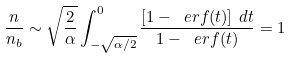<formula> <loc_0><loc_0><loc_500><loc_500>\frac { n } { n _ { b } } \sim \sqrt { \frac { 2 } { \alpha } } \int _ { - \sqrt { \alpha / 2 } } ^ { 0 } \frac { \left [ 1 - \ e r f ( t ) \right ] \, d t } { 1 - \ e r f ( t ) } = 1</formula> 